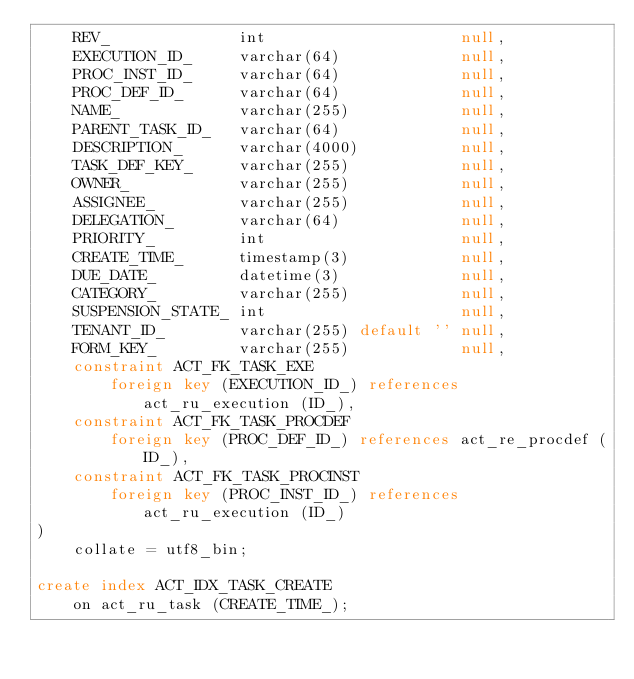<code> <loc_0><loc_0><loc_500><loc_500><_SQL_>    REV_              int                     null,
    EXECUTION_ID_     varchar(64)             null,
    PROC_INST_ID_     varchar(64)             null,
    PROC_DEF_ID_      varchar(64)             null,
    NAME_             varchar(255)            null,
    PARENT_TASK_ID_   varchar(64)             null,
    DESCRIPTION_      varchar(4000)           null,
    TASK_DEF_KEY_     varchar(255)            null,
    OWNER_            varchar(255)            null,
    ASSIGNEE_         varchar(255)            null,
    DELEGATION_       varchar(64)             null,
    PRIORITY_         int                     null,
    CREATE_TIME_      timestamp(3)            null,
    DUE_DATE_         datetime(3)             null,
    CATEGORY_         varchar(255)            null,
    SUSPENSION_STATE_ int                     null,
    TENANT_ID_        varchar(255) default '' null,
    FORM_KEY_         varchar(255)            null,
    constraint ACT_FK_TASK_EXE
        foreign key (EXECUTION_ID_) references act_ru_execution (ID_),
    constraint ACT_FK_TASK_PROCDEF
        foreign key (PROC_DEF_ID_) references act_re_procdef (ID_),
    constraint ACT_FK_TASK_PROCINST
        foreign key (PROC_INST_ID_) references act_ru_execution (ID_)
)
    collate = utf8_bin;

create index ACT_IDX_TASK_CREATE
    on act_ru_task (CREATE_TIME_);

</code> 